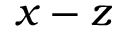<formula> <loc_0><loc_0><loc_500><loc_500>x - z</formula> 